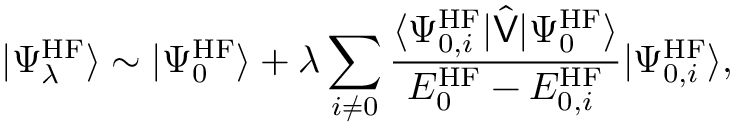<formula> <loc_0><loc_0><loc_500><loc_500>| \Psi _ { \lambda } ^ { H F } \rangle \sim | \Psi _ { 0 } ^ { H F } \rangle + \lambda \sum _ { i \neq 0 } \frac { \langle \Psi _ { 0 , i } ^ { H F } | \hat { V } | \Psi _ { 0 } ^ { H F } \rangle } { E _ { 0 } ^ { H F } - E _ { 0 , i } ^ { H F } } | \Psi _ { 0 , i } ^ { H F } \rangle ,</formula> 